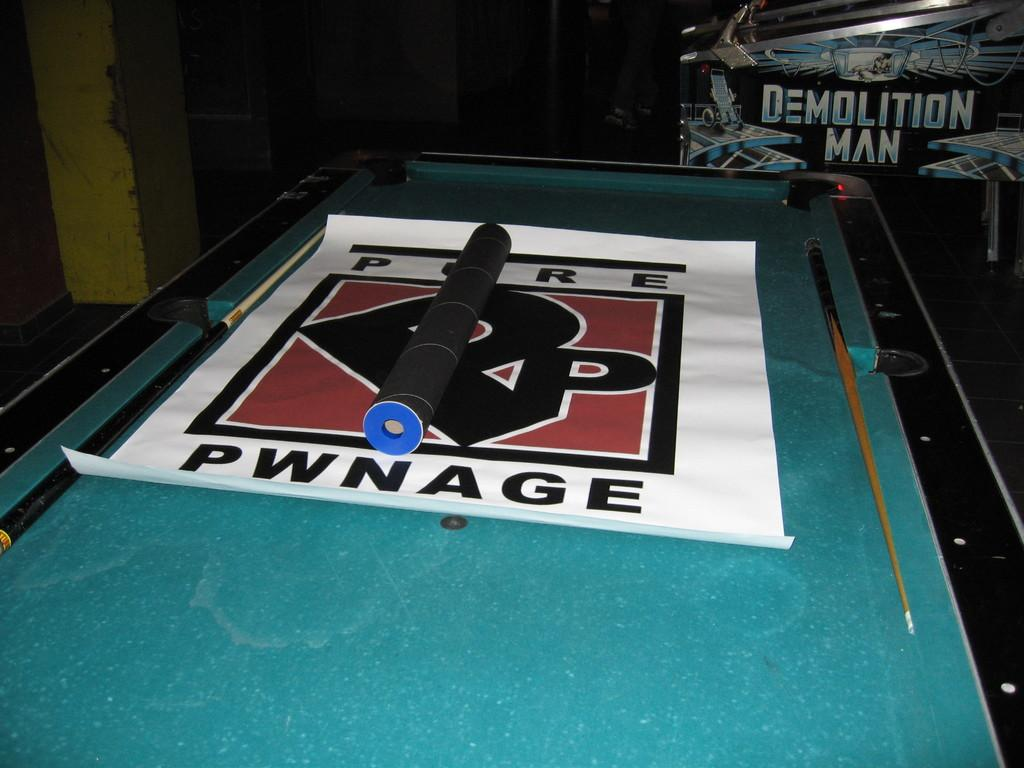What type of equipment is visible in the image? There are snooker cue sticks in the image. What else can be seen in the image besides the snooker cue sticks? There is a banner and an object on the snooker board visible in the image. What is located in the background of the image? There is a board in the background of the image. What type of light is shining on the snooker cue sticks in the image? There is no specific light source mentioned in the image, so we cannot determine the type of light shining on the snooker cue sticks. What organization is hosting the event in the image? There is no information about an event or organization in the image. 